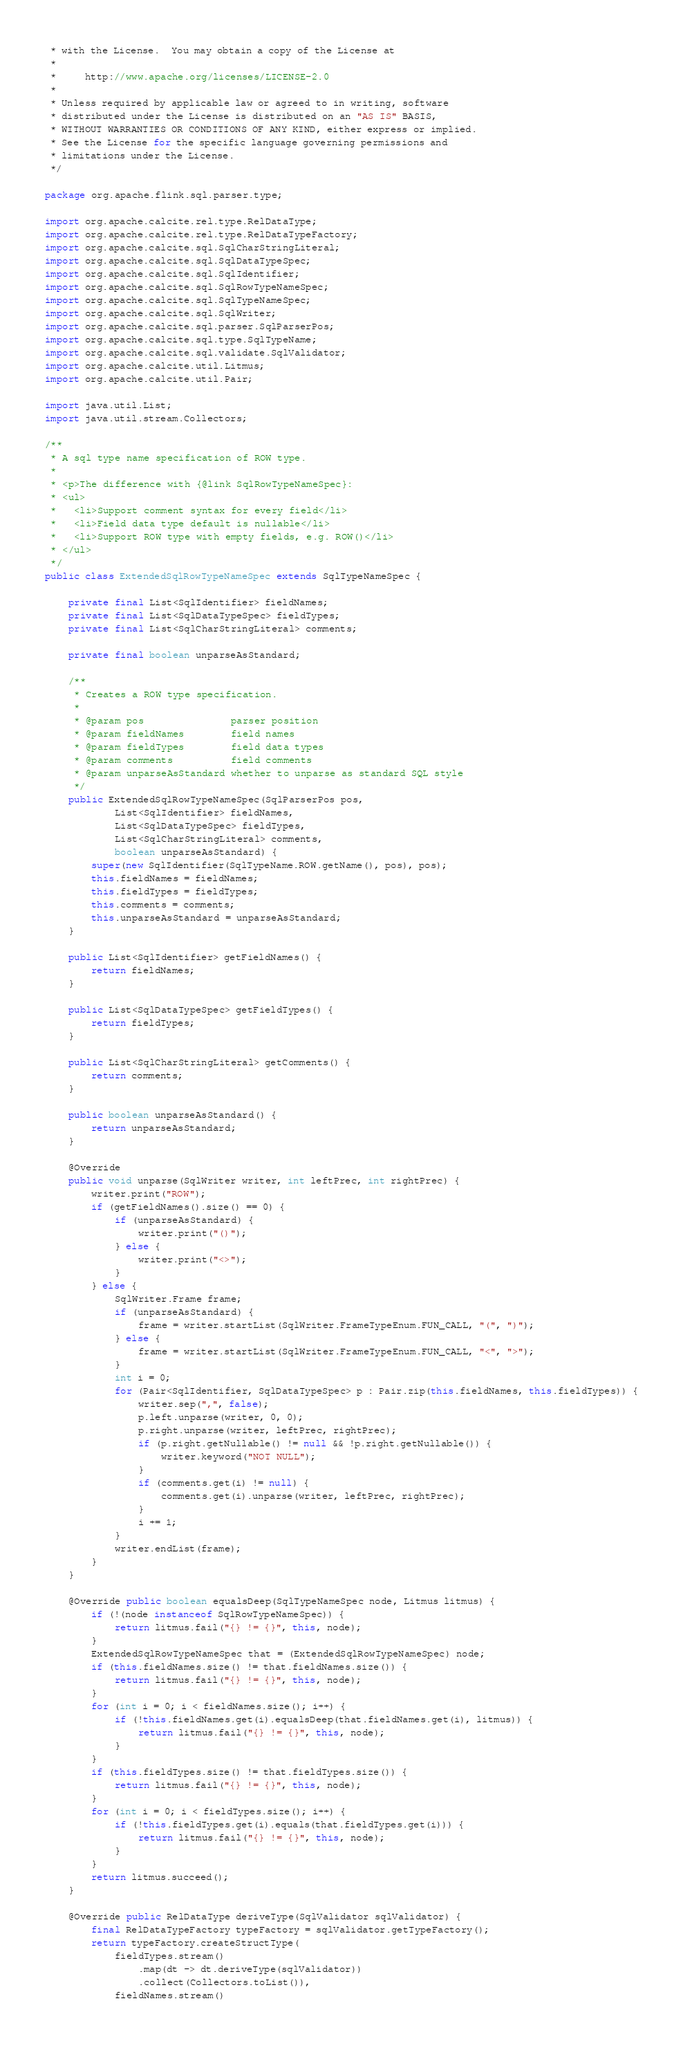Convert code to text. <code><loc_0><loc_0><loc_500><loc_500><_Java_> * with the License.  You may obtain a copy of the License at
 *
 *     http://www.apache.org/licenses/LICENSE-2.0
 *
 * Unless required by applicable law or agreed to in writing, software
 * distributed under the License is distributed on an "AS IS" BASIS,
 * WITHOUT WARRANTIES OR CONDITIONS OF ANY KIND, either express or implied.
 * See the License for the specific language governing permissions and
 * limitations under the License.
 */

package org.apache.flink.sql.parser.type;

import org.apache.calcite.rel.type.RelDataType;
import org.apache.calcite.rel.type.RelDataTypeFactory;
import org.apache.calcite.sql.SqlCharStringLiteral;
import org.apache.calcite.sql.SqlDataTypeSpec;
import org.apache.calcite.sql.SqlIdentifier;
import org.apache.calcite.sql.SqlRowTypeNameSpec;
import org.apache.calcite.sql.SqlTypeNameSpec;
import org.apache.calcite.sql.SqlWriter;
import org.apache.calcite.sql.parser.SqlParserPos;
import org.apache.calcite.sql.type.SqlTypeName;
import org.apache.calcite.sql.validate.SqlValidator;
import org.apache.calcite.util.Litmus;
import org.apache.calcite.util.Pair;

import java.util.List;
import java.util.stream.Collectors;

/**
 * A sql type name specification of ROW type.
 *
 * <p>The difference with {@link SqlRowTypeNameSpec}:
 * <ul>
 *   <li>Support comment syntax for every field</li>
 *   <li>Field data type default is nullable</li>
 *   <li>Support ROW type with empty fields, e.g. ROW()</li>
 * </ul>
 */
public class ExtendedSqlRowTypeNameSpec extends SqlTypeNameSpec {

	private final List<SqlIdentifier> fieldNames;
	private final List<SqlDataTypeSpec> fieldTypes;
	private final List<SqlCharStringLiteral> comments;

	private final boolean unparseAsStandard;

	/**
	 * Creates a ROW type specification.
	 *
	 * @param pos               parser position
	 * @param fieldNames        field names
	 * @param fieldTypes        field data types
	 * @param comments          field comments
	 * @param unparseAsStandard whether to unparse as standard SQL style
	 */
	public ExtendedSqlRowTypeNameSpec(SqlParserPos pos,
			List<SqlIdentifier> fieldNames,
			List<SqlDataTypeSpec> fieldTypes,
			List<SqlCharStringLiteral> comments,
			boolean unparseAsStandard) {
		super(new SqlIdentifier(SqlTypeName.ROW.getName(), pos), pos);
		this.fieldNames = fieldNames;
		this.fieldTypes = fieldTypes;
		this.comments = comments;
		this.unparseAsStandard = unparseAsStandard;
	}

	public List<SqlIdentifier> getFieldNames() {
		return fieldNames;
	}

	public List<SqlDataTypeSpec> getFieldTypes() {
		return fieldTypes;
	}

	public List<SqlCharStringLiteral> getComments() {
		return comments;
	}

	public boolean unparseAsStandard() {
		return unparseAsStandard;
	}

	@Override
	public void unparse(SqlWriter writer, int leftPrec, int rightPrec) {
		writer.print("ROW");
		if (getFieldNames().size() == 0) {
			if (unparseAsStandard) {
				writer.print("()");
			} else {
				writer.print("<>");
			}
		} else {
			SqlWriter.Frame frame;
			if (unparseAsStandard) {
				frame = writer.startList(SqlWriter.FrameTypeEnum.FUN_CALL, "(", ")");
			} else {
				frame = writer.startList(SqlWriter.FrameTypeEnum.FUN_CALL, "<", ">");
			}
			int i = 0;
			for (Pair<SqlIdentifier, SqlDataTypeSpec> p : Pair.zip(this.fieldNames, this.fieldTypes)) {
				writer.sep(",", false);
				p.left.unparse(writer, 0, 0);
				p.right.unparse(writer, leftPrec, rightPrec);
				if (p.right.getNullable() != null && !p.right.getNullable()) {
					writer.keyword("NOT NULL");
				}
				if (comments.get(i) != null) {
					comments.get(i).unparse(writer, leftPrec, rightPrec);
				}
				i += 1;
			}
			writer.endList(frame);
		}
	}

	@Override public boolean equalsDeep(SqlTypeNameSpec node, Litmus litmus) {
		if (!(node instanceof SqlRowTypeNameSpec)) {
			return litmus.fail("{} != {}", this, node);
		}
		ExtendedSqlRowTypeNameSpec that = (ExtendedSqlRowTypeNameSpec) node;
		if (this.fieldNames.size() != that.fieldNames.size()) {
			return litmus.fail("{} != {}", this, node);
		}
		for (int i = 0; i < fieldNames.size(); i++) {
			if (!this.fieldNames.get(i).equalsDeep(that.fieldNames.get(i), litmus)) {
				return litmus.fail("{} != {}", this, node);
			}
		}
		if (this.fieldTypes.size() != that.fieldTypes.size()) {
			return litmus.fail("{} != {}", this, node);
		}
		for (int i = 0; i < fieldTypes.size(); i++) {
			if (!this.fieldTypes.get(i).equals(that.fieldTypes.get(i))) {
				return litmus.fail("{} != {}", this, node);
			}
		}
		return litmus.succeed();
	}

	@Override public RelDataType deriveType(SqlValidator sqlValidator) {
		final RelDataTypeFactory typeFactory = sqlValidator.getTypeFactory();
		return typeFactory.createStructType(
			fieldTypes.stream()
				.map(dt -> dt.deriveType(sqlValidator))
				.collect(Collectors.toList()),
			fieldNames.stream()</code> 